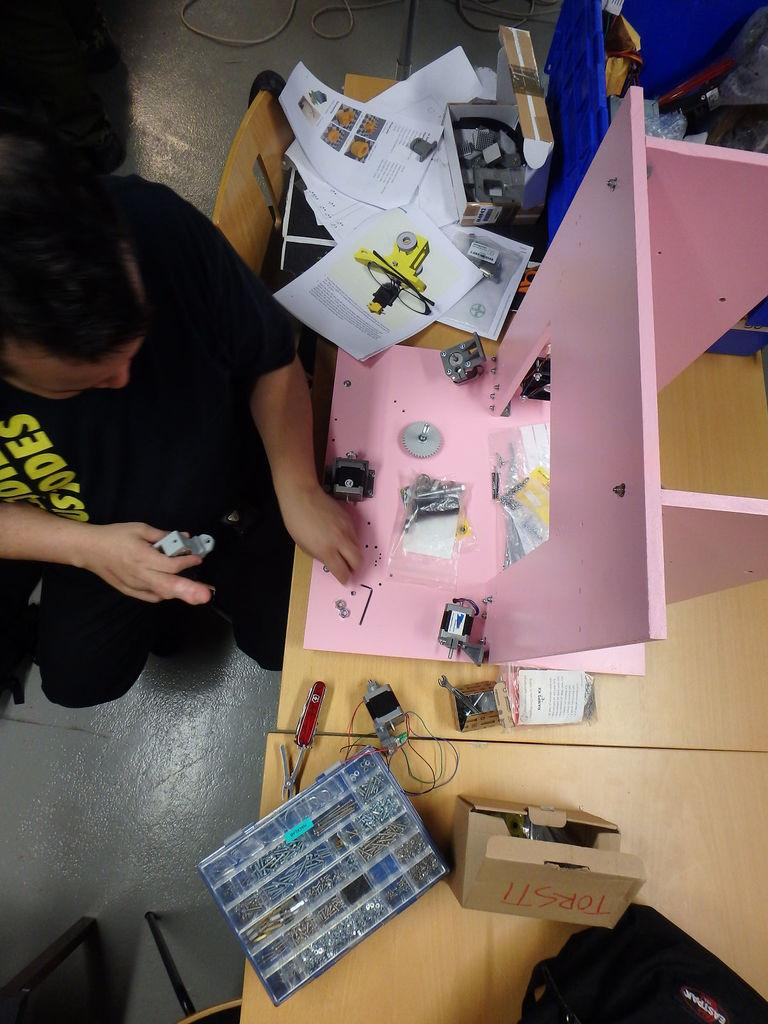Who is present in the image? There is a man in the image. What is the man wearing? The man is wearing a black costume. What is the man's position in the image? The man is sitting on the ground. What other object can be seen in the image? There is a table in the image. What is on the table? There are many things on the table. How many boys are observing the car in the image? There is no car or boys present in the image. 